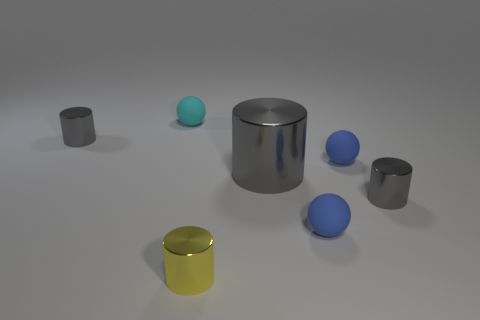How many metal objects are spheres or tiny yellow cylinders?
Your response must be concise. 1. Are there any other things that have the same color as the big cylinder?
Keep it short and to the point. Yes. There is a small gray object that is behind the large gray thing; does it have the same shape as the big gray thing to the right of the yellow metallic object?
Your response must be concise. Yes. How many objects are yellow cylinders or tiny yellow shiny cylinders right of the cyan object?
Provide a succinct answer. 1. What number of other objects are the same size as the cyan ball?
Your response must be concise. 5. Are the tiny gray object that is to the left of the big gray cylinder and the blue thing in front of the large metal cylinder made of the same material?
Your response must be concise. No. There is a large shiny object; what number of large gray objects are behind it?
Offer a terse response. 0. How many gray objects are either big objects or shiny objects?
Your answer should be compact. 3. What material is the cyan object that is the same size as the yellow metal cylinder?
Provide a short and direct response. Rubber. What is the shape of the tiny matte object that is behind the big gray object and right of the big object?
Provide a succinct answer. Sphere. 